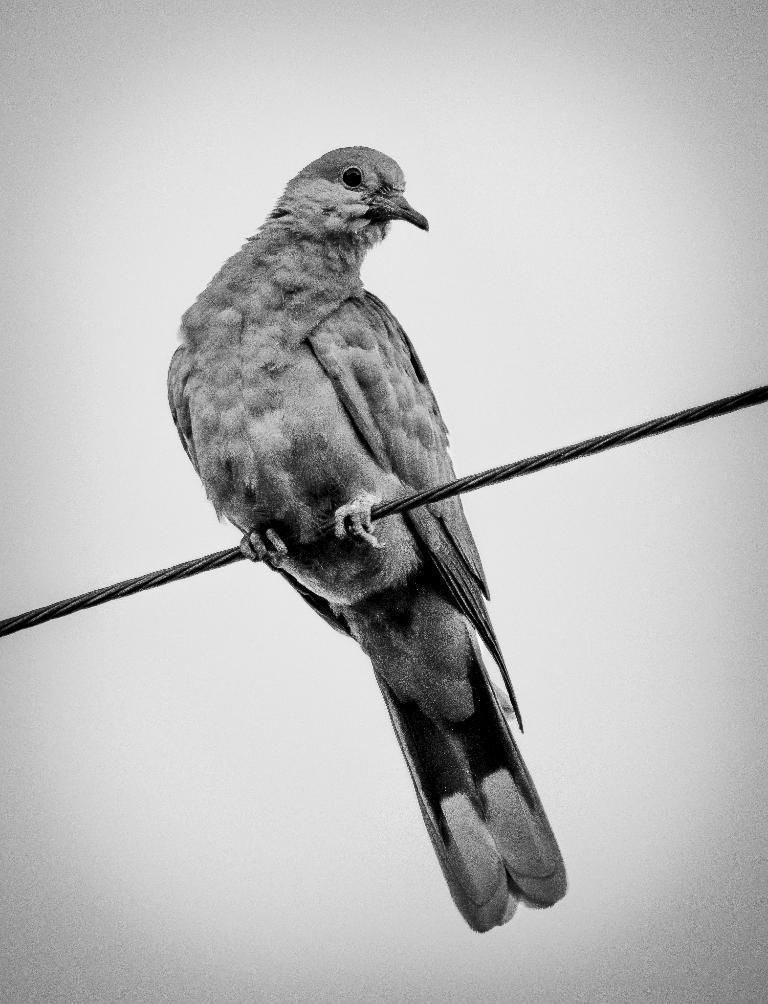Describe this image in one or two sentences. In this picture there is a bird which is standing on the electric wire. In the back I can see the sky. 